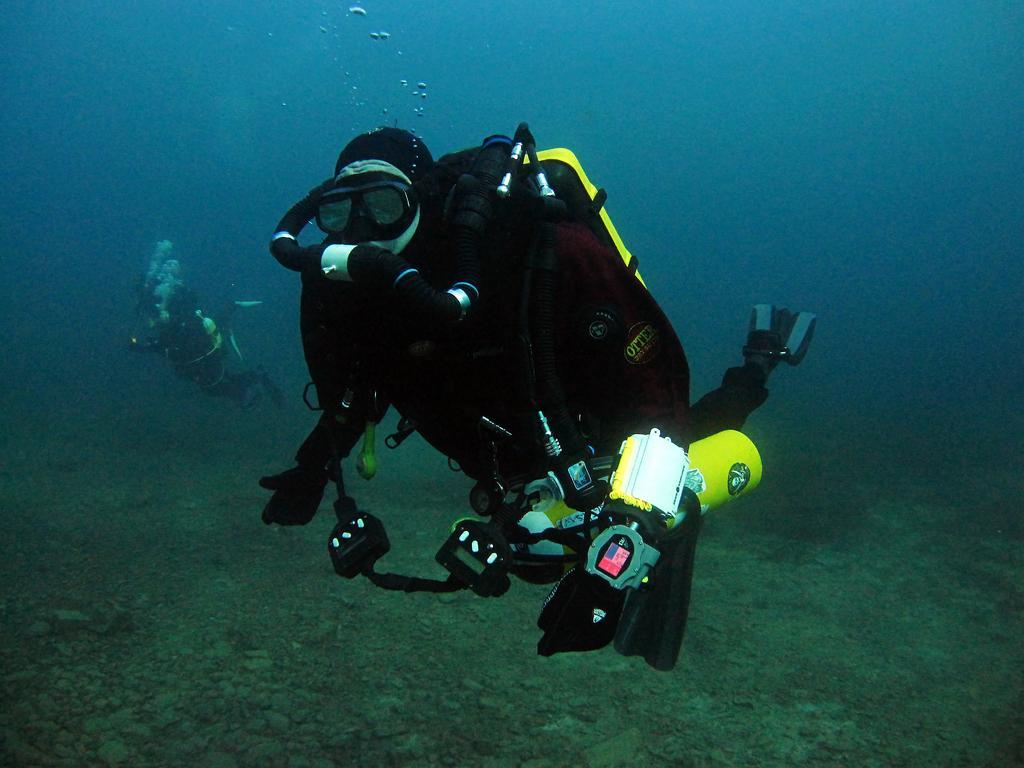Can you describe this image briefly? In this image, I can see two persons under the water with the oxygen cylinders and swim fins. 